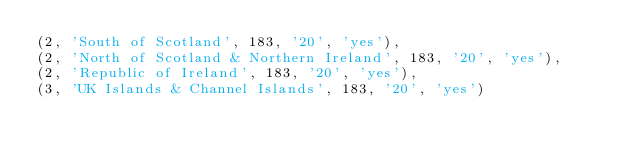<code> <loc_0><loc_0><loc_500><loc_500><_SQL_>(2, 'South of Scotland', 183, '20', 'yes'),
(2, 'North of Scotland & Northern Ireland', 183, '20', 'yes'),
(2, 'Republic of Ireland', 183, '20', 'yes'),
(3, 'UK Islands & Channel Islands', 183, '20', 'yes')</code> 